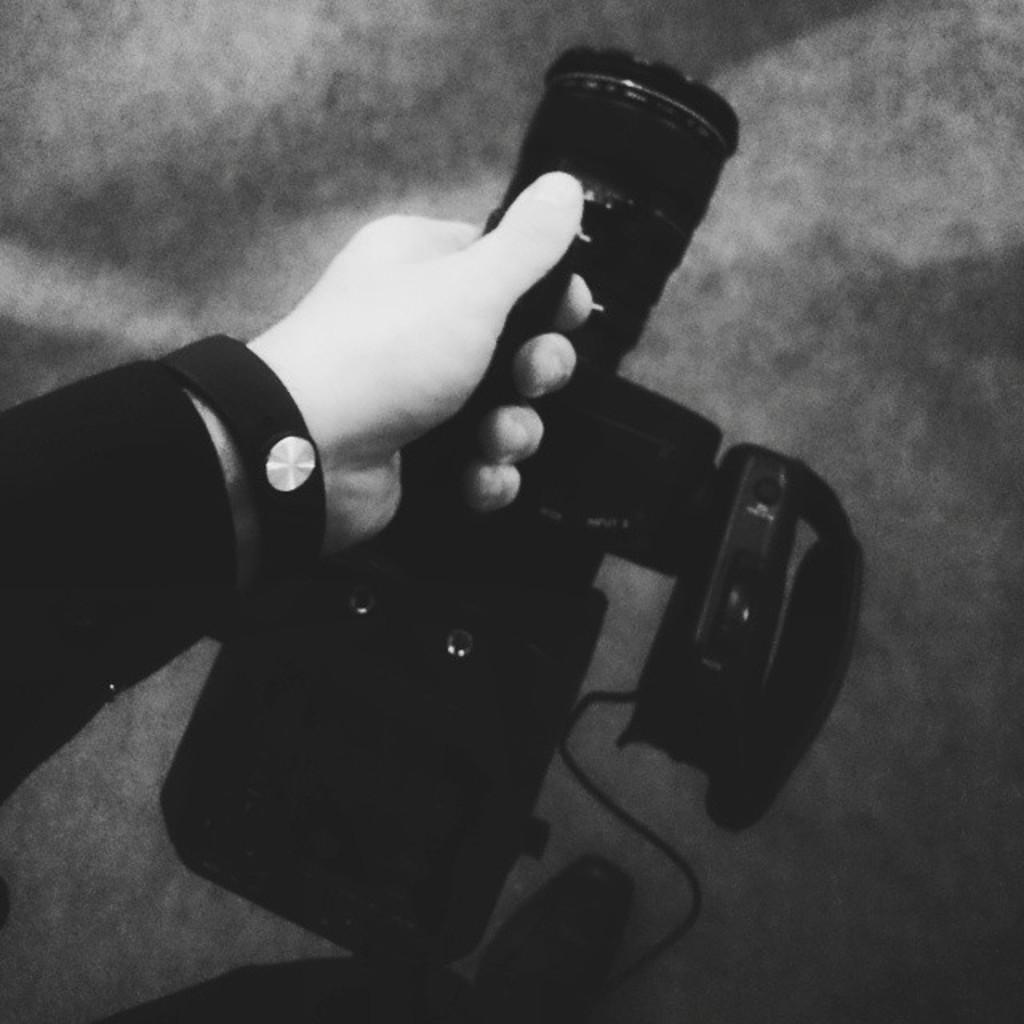Describe this image in one or two sentences. In this picture there is a video recorder in a hand in the image. 